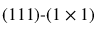Convert formula to latex. <formula><loc_0><loc_0><loc_500><loc_500>( 1 1 1 ) ( 1 \times 1 )</formula> 